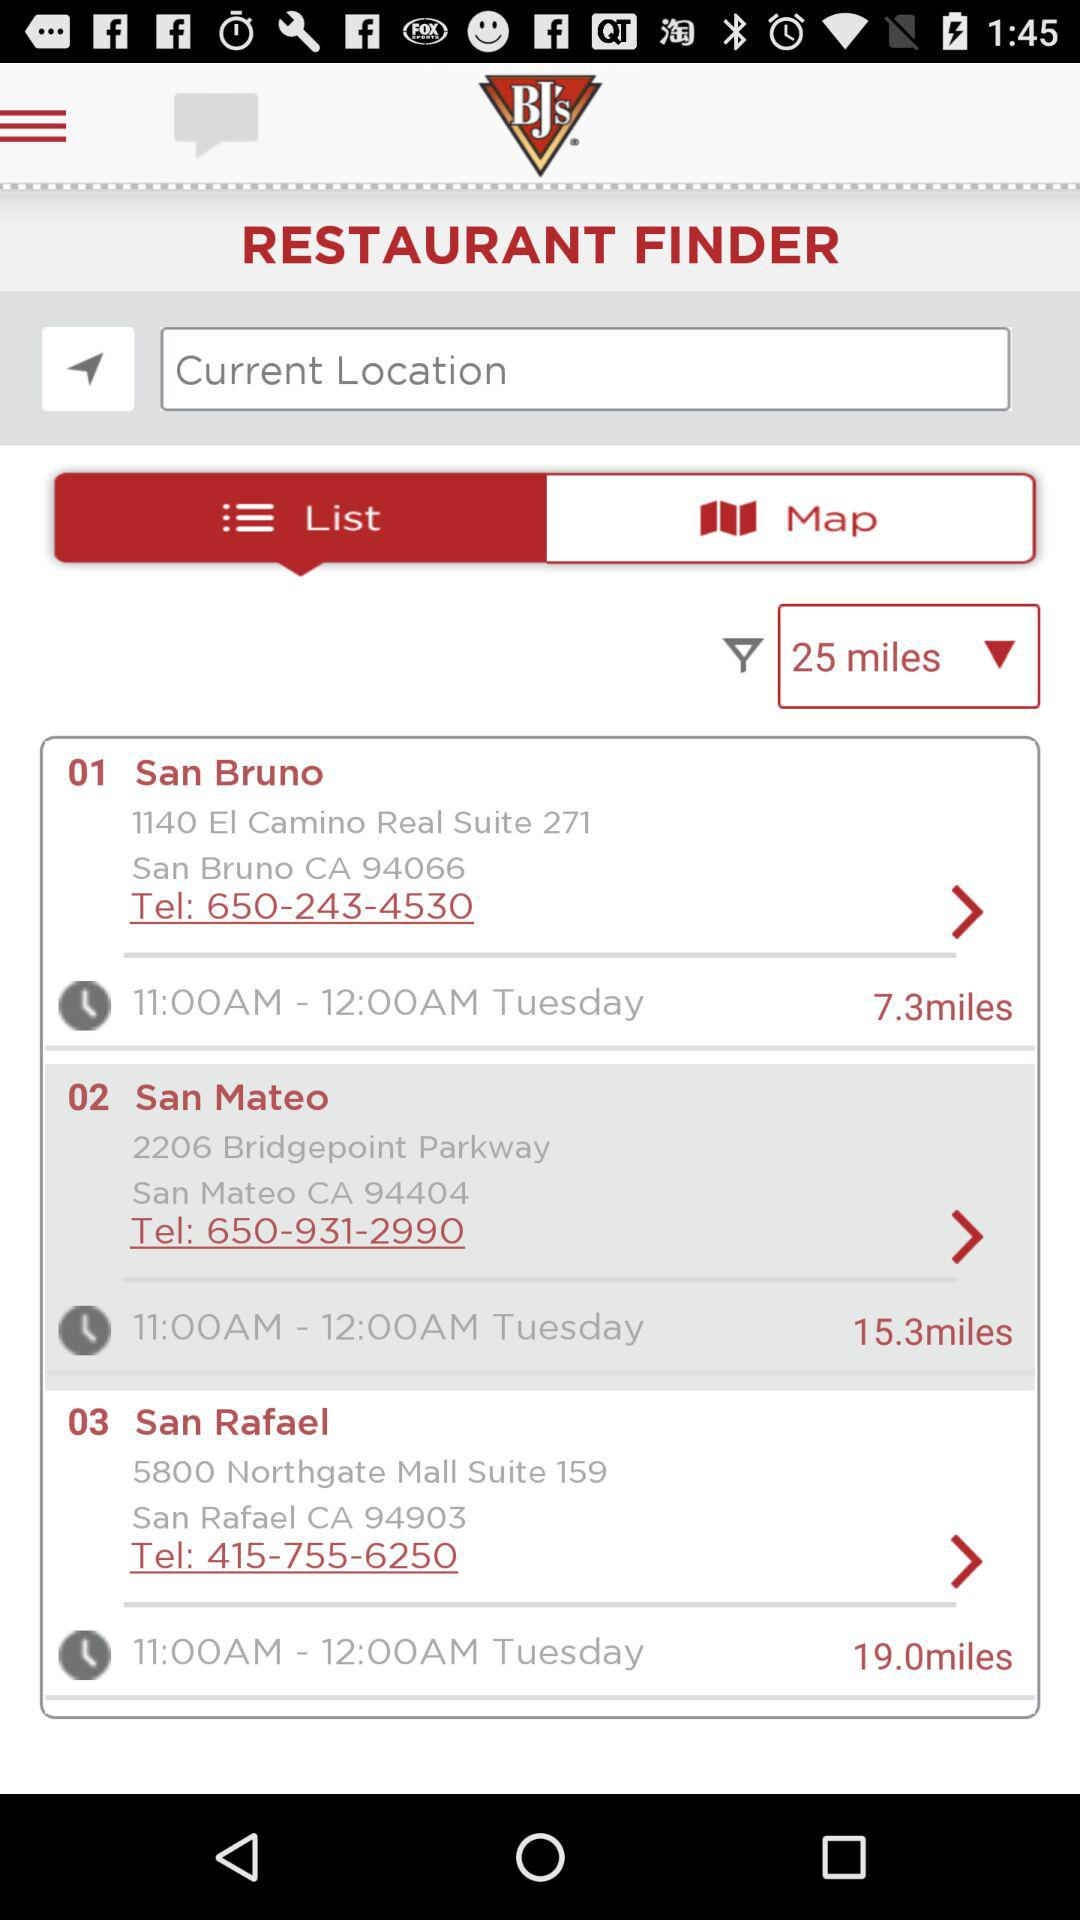What is the contact number for the restaurant in San Bruno? The contact number is 650-243-4530. 